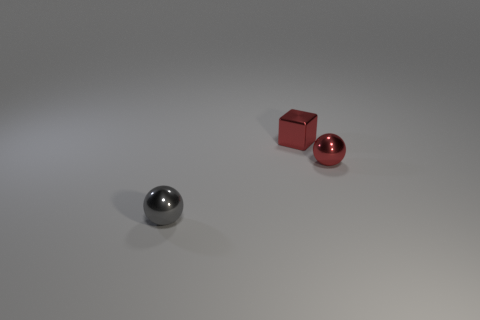Add 1 blue things. How many objects exist? 4 Subtract all cubes. How many objects are left? 2 Subtract 0 brown spheres. How many objects are left? 3 Subtract all metallic blocks. Subtract all gray rubber blocks. How many objects are left? 2 Add 2 gray metallic balls. How many gray metallic balls are left? 3 Add 1 red metallic things. How many red metallic things exist? 3 